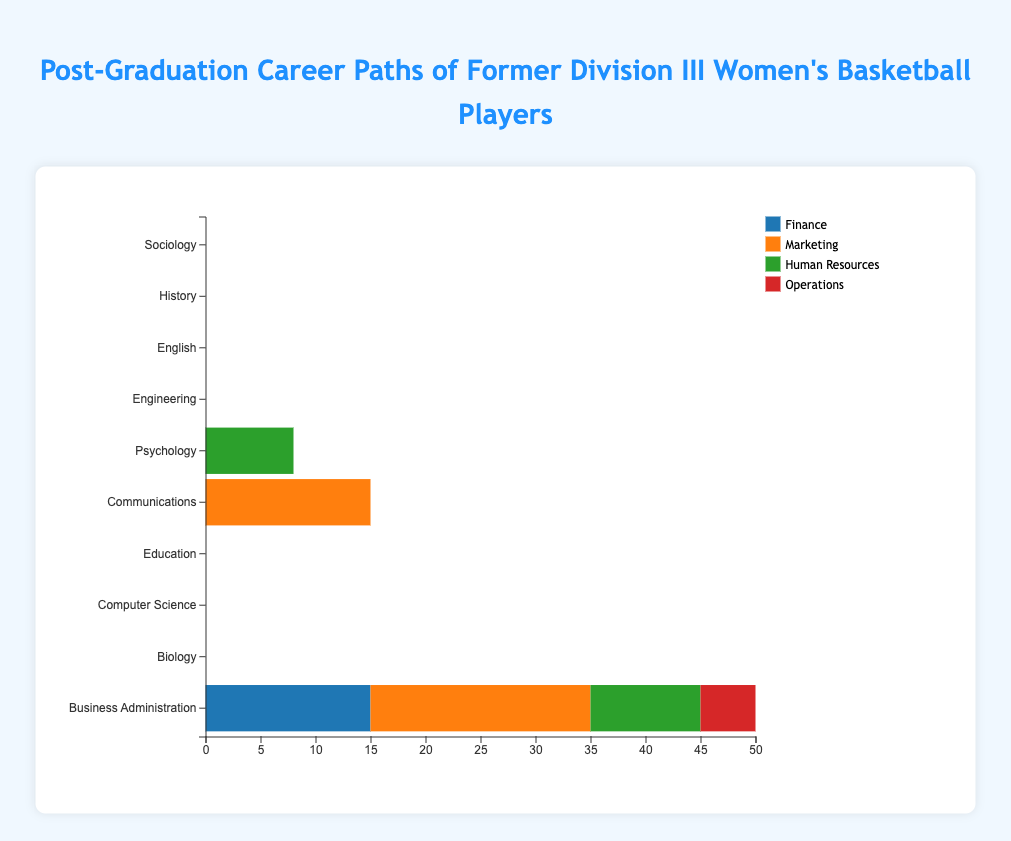What major has the highest number of graduates in a single industry? Look at the lengths of the bars for each major in each industry to see which one is the longest.
Answer: Education with K-12 Teaching (25) Which major has more graduates in Marketing: Business Administration or Communications? Compare the lengths of the "Marketing" sections in the horizontal bars for both majors.
Answer: Communications (15) How many graduates from Psychology work in Research and Human Resources combined? Add the lengths of the sections representing Research (7) and Human Resources (8) for Psychology.
Answer: 15 Which major has the fewest graduates in total? Sum the lengths of all industries for each major and compare.
Answer: History (30) Are there more graduates in the Healthcare industry from Biology or more in Mechanical Engineering from Engineering? Compare the lengths of the "Healthcare" section for Biology and "Mechanical Engineering" section for Engineering.
Answer: More in Healthcare from Biology (10 vs. 12) What is the most common industry for graduates with a major in Computer Science? Identify the longest section in the horizontal bar for Computer Science.
Answer: Software Development (18) Which industry employs the most graduates from Business Administration? Identify the longest section in the horizontal bar for Business Administration.
Answer: Marketing (20) How many graduates in total come from the Sociology major? Sum the lengths of all sections for Sociology.
Answer: 40 Which major has the most diverse distribution across industries, meaning more evenly spread out? Compare the relative lengths of the sections in each bar; the more even the lengths, the more evenly distributed the graduates.
Answer: Education Is there any industry where graduates from at least three different majors contribute equally to the number of employees? Look for industries where three sections from different majors are of the same length.
Answer: No 